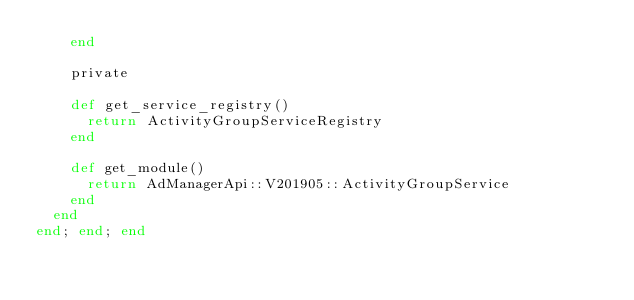Convert code to text. <code><loc_0><loc_0><loc_500><loc_500><_Ruby_>    end

    private

    def get_service_registry()
      return ActivityGroupServiceRegistry
    end

    def get_module()
      return AdManagerApi::V201905::ActivityGroupService
    end
  end
end; end; end
</code> 